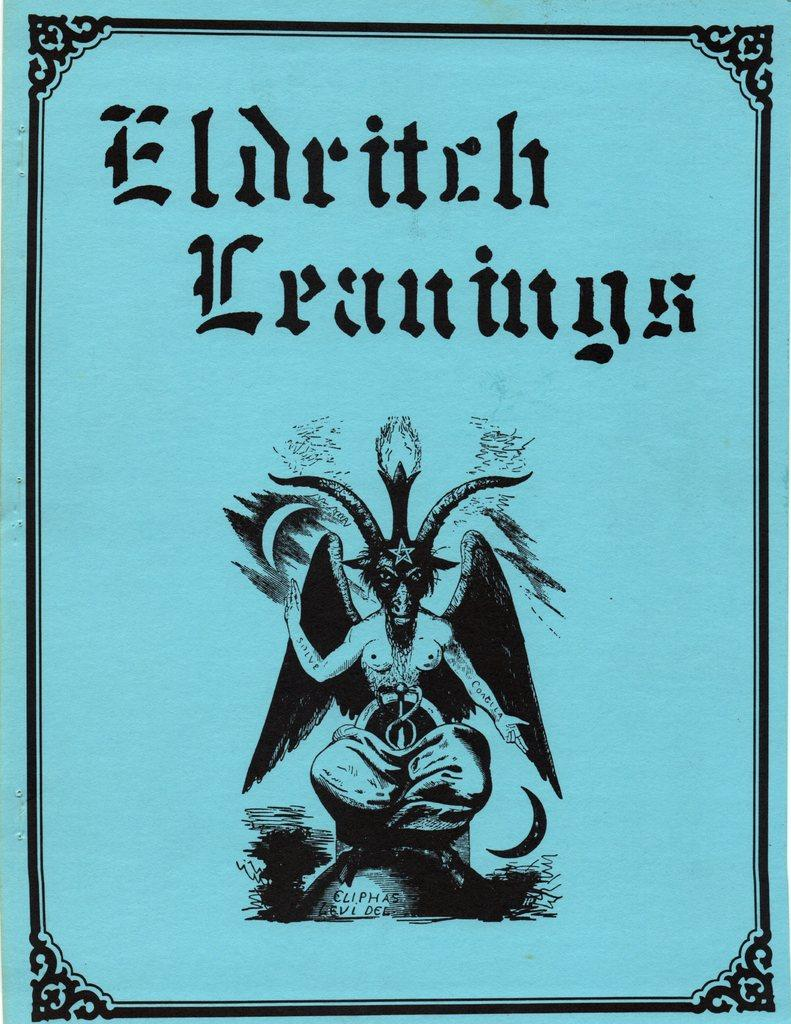Provide a one-sentence caption for the provided image. a blue poster with a title that says 'eldritch leanings'. 